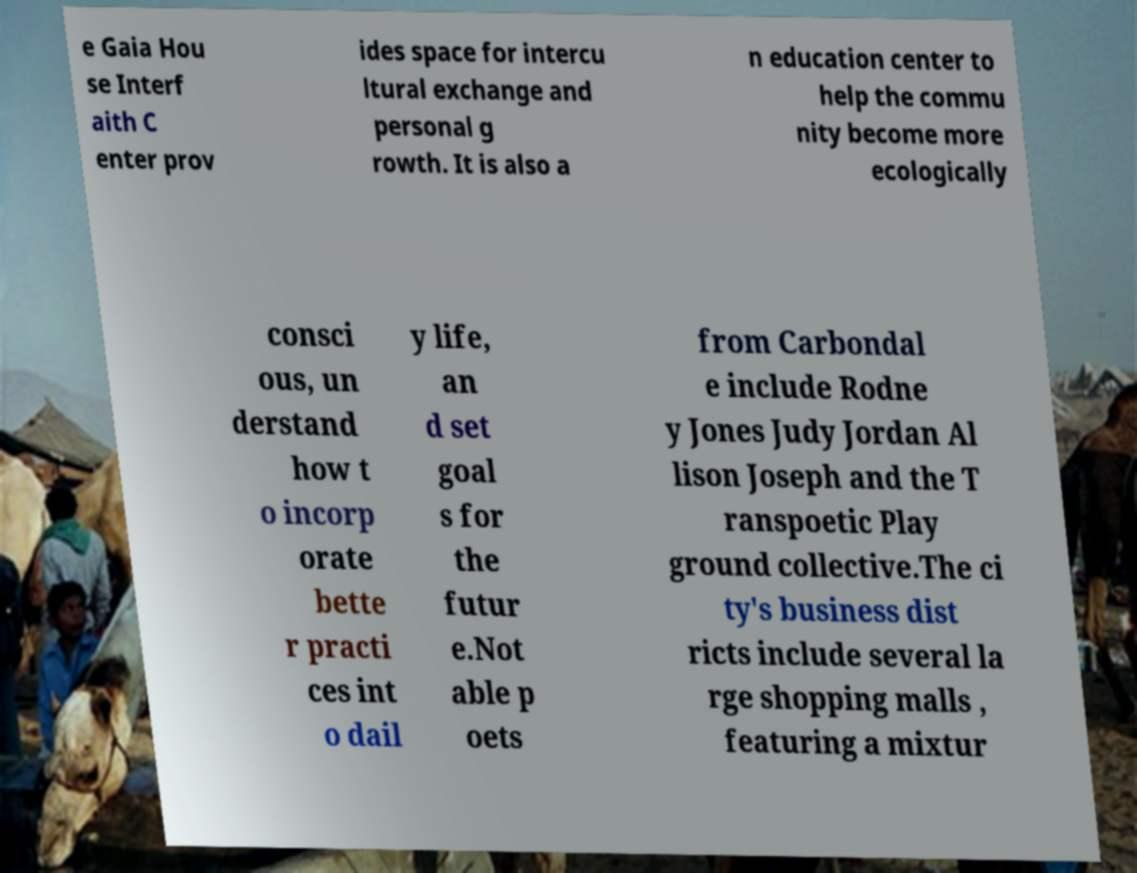What messages or text are displayed in this image? I need them in a readable, typed format. e Gaia Hou se Interf aith C enter prov ides space for intercu ltural exchange and personal g rowth. It is also a n education center to help the commu nity become more ecologically consci ous, un derstand how t o incorp orate bette r practi ces int o dail y life, an d set goal s for the futur e.Not able p oets from Carbondal e include Rodne y Jones Judy Jordan Al lison Joseph and the T ranspoetic Play ground collective.The ci ty's business dist ricts include several la rge shopping malls , featuring a mixtur 